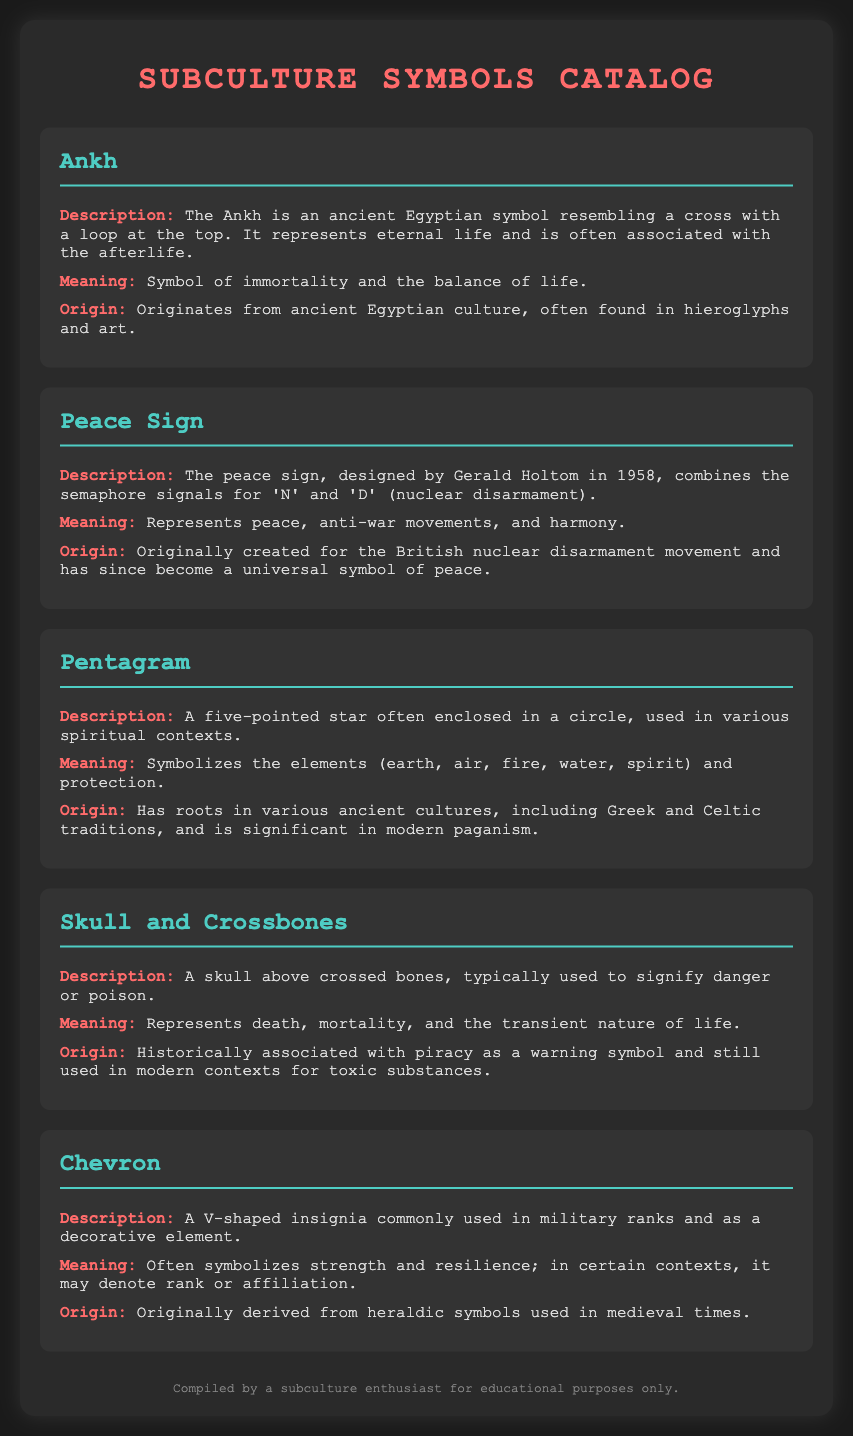What is the first symbol listed? The first symbol listed in the document is the Ankh.
Answer: Ankh What does the Peace Sign represent? The document states that the Peace Sign represents peace, anti-war movements, and harmony.
Answer: Peace, anti-war movements, and harmony What shape is the Pentagram? The Pentagram is described as a five-pointed star often enclosed in a circle.
Answer: Five-pointed star What does the Skull and Crossbones symbolize? It is noted in the document that the Skull and Crossbones represents death, mortality, and the transient nature of life.
Answer: Death, mortality, and the transient nature of life From which culture does the Ankh originate? The Ankh originates from ancient Egyptian culture.
Answer: Ancient Egyptian culture What is a common use for the Chevron symbol? The Chevron is commonly used in military ranks and as a decorative element.
Answer: Military ranks What year was the Peace Sign designed? The Peace Sign was designed in 1958.
Answer: 1958 Which elements does the Pentagram symbolize? The Pentagram symbolizes earth, air, fire, water, and spirit.
Answer: Earth, air, fire, water, spirit What historical association does the Skull and Crossbones have? Historically, it is associated with piracy as a warning symbol.
Answer: Piracy 